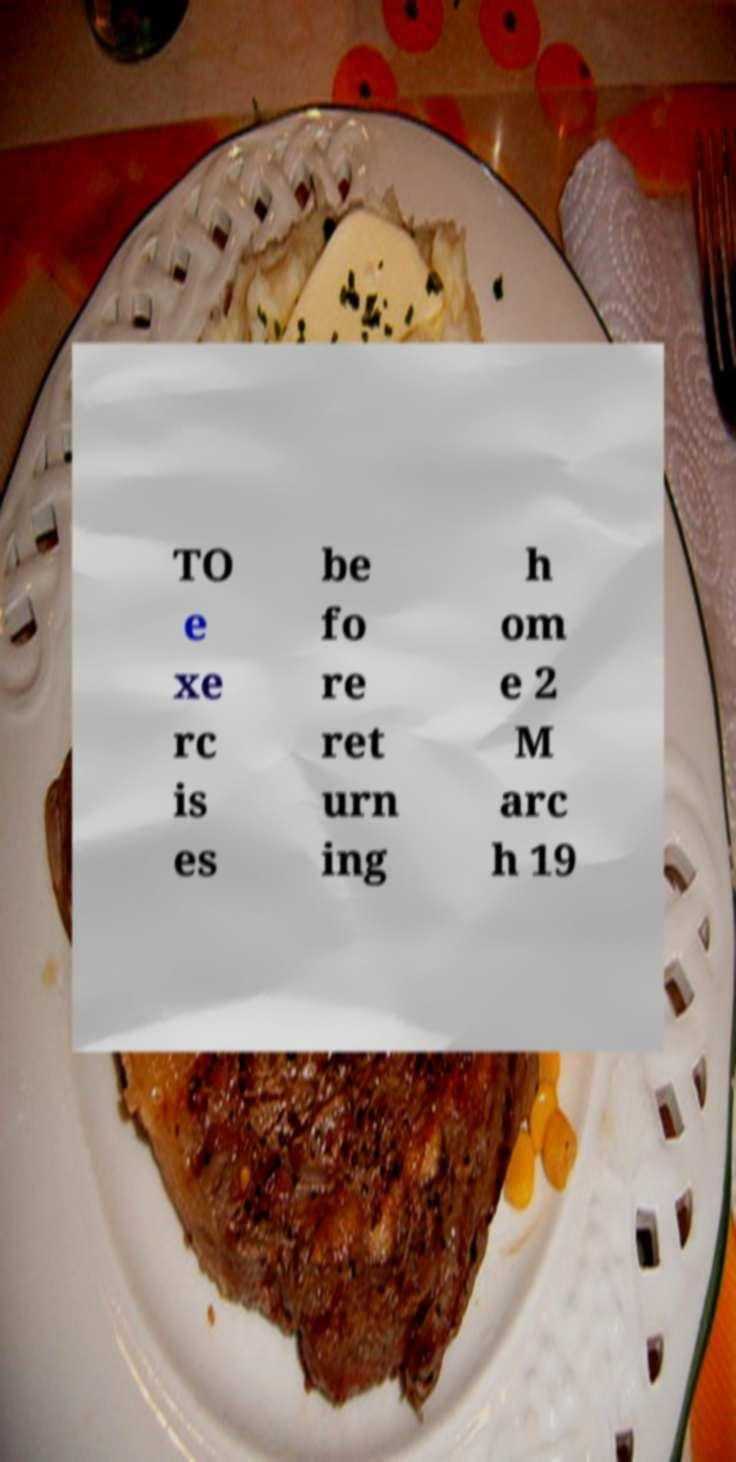Please read and relay the text visible in this image. What does it say? TO e xe rc is es be fo re ret urn ing h om e 2 M arc h 19 